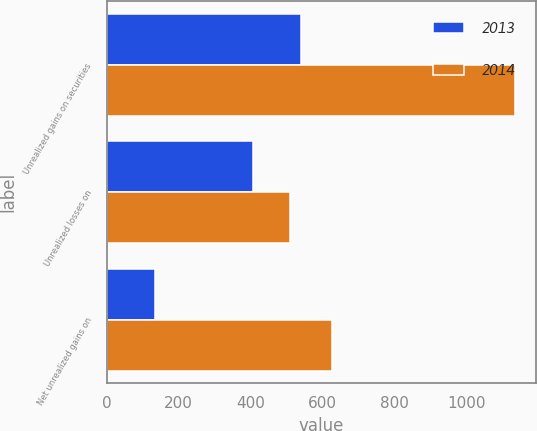<chart> <loc_0><loc_0><loc_500><loc_500><stacked_bar_chart><ecel><fcel>Unrealized gains on securities<fcel>Unrealized losses on<fcel>Net unrealized gains on<nl><fcel>2013<fcel>541<fcel>407<fcel>134<nl><fcel>2014<fcel>1137<fcel>511<fcel>626<nl></chart> 